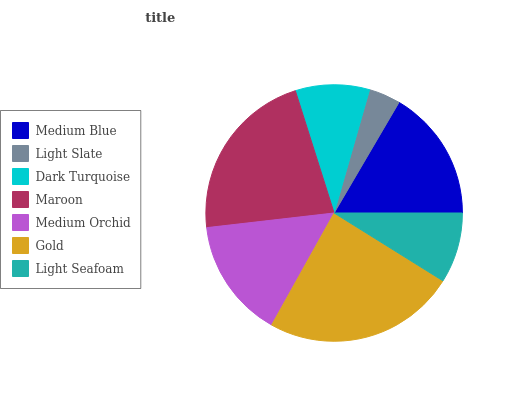Is Light Slate the minimum?
Answer yes or no. Yes. Is Gold the maximum?
Answer yes or no. Yes. Is Dark Turquoise the minimum?
Answer yes or no. No. Is Dark Turquoise the maximum?
Answer yes or no. No. Is Dark Turquoise greater than Light Slate?
Answer yes or no. Yes. Is Light Slate less than Dark Turquoise?
Answer yes or no. Yes. Is Light Slate greater than Dark Turquoise?
Answer yes or no. No. Is Dark Turquoise less than Light Slate?
Answer yes or no. No. Is Medium Orchid the high median?
Answer yes or no. Yes. Is Medium Orchid the low median?
Answer yes or no. Yes. Is Light Slate the high median?
Answer yes or no. No. Is Light Slate the low median?
Answer yes or no. No. 